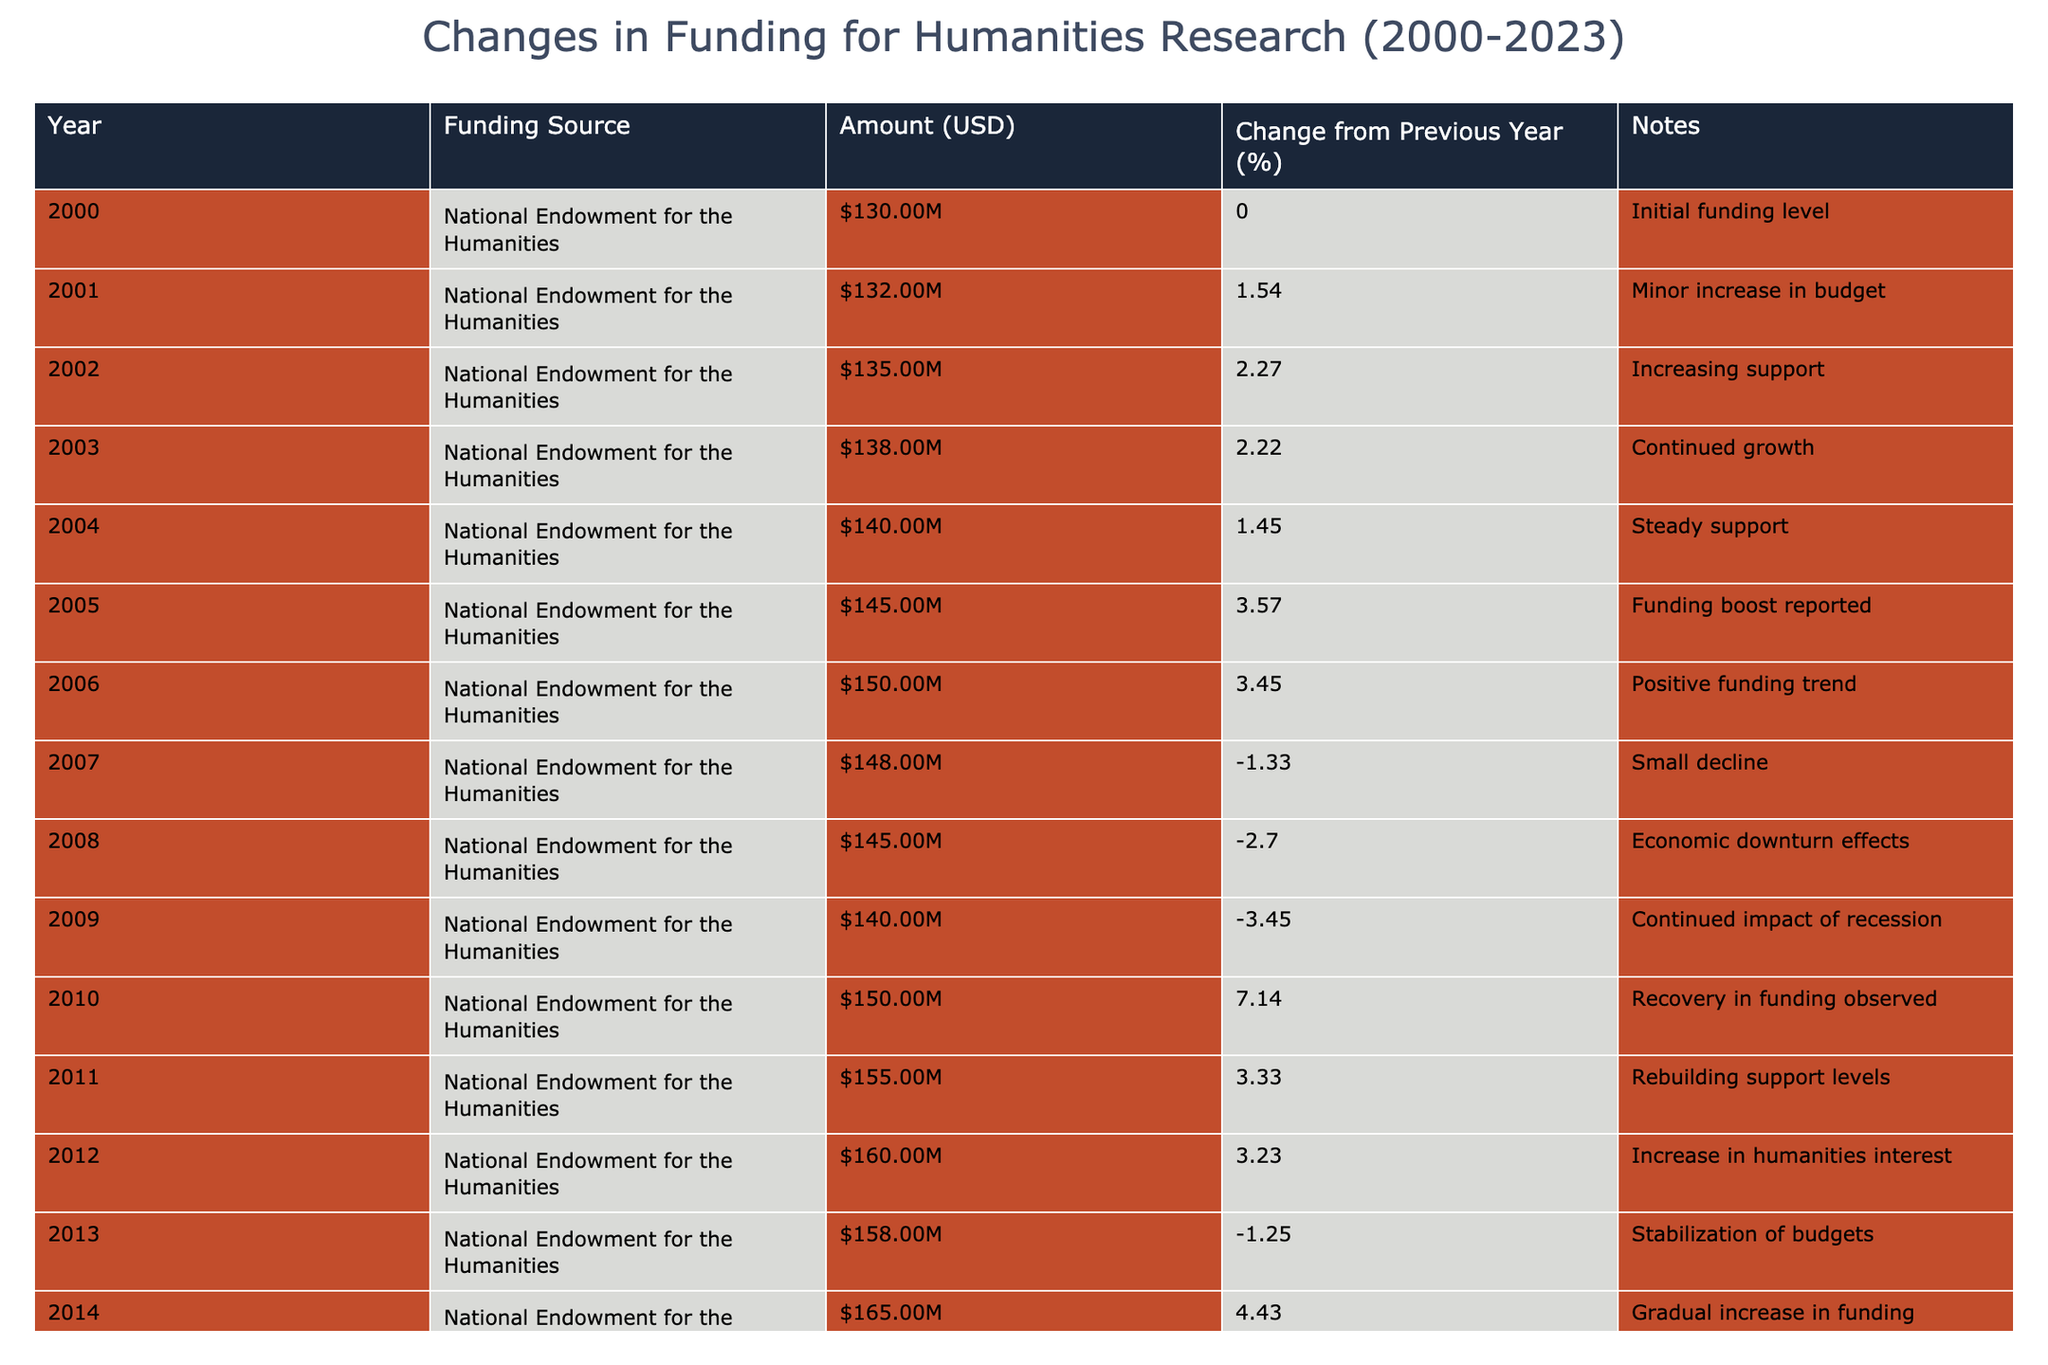What was the funding amount for the National Endowment for the Humanities in 2005? The table shows the funding amount for the year 2005 specifically, which is listed as 145,000,000 USD.
Answer: 145000000 What percentage change occurred in funding from 2017 to 2018? The funding amount in 2017 was 175,000,000 USD and in 2018 it was 180,000,000 USD. The percentage change is calculated as ((180 - 175) / 175) * 100 = 2.86%.
Answer: 2.86% Was there a funding decrease in 2007? The funding for 2007 was 148,000,000 USD, which is lower than the previous year's funding of 150,000,000 USD. This indicates a decline.
Answer: Yes What was the average funding amount over the entire period from 2000 to 2023? The sum of the funding amounts from 2000 to 2023 is 3,361,000,000 USD. There are 24 data points, so the average is calculated as 3,361,000,000 / 24 = 140,041,667 USD.
Answer: 140041667 Did the funding in 2023 surpass the funding in 2000? The funding in 2023 was 200,000,000 USD, which is higher than the funding in 2000 of 130,000,000 USD. Hence, it confirms the increase.
Answer: Yes What was the highest funding amount recorded during this period, and in which year did it occur? The highest funding amount in the table is 200,000,000 USD in the year 2023.
Answer: 200000000 in 2023 What was the percentage change from 2014 to 2015? In 2014, the funding was 165,000,000 USD and in 2015 it was 170,000,000 USD. The percentage change is computed as ((170 - 165) / 165) * 100 = 3.03%.
Answer: 3.03% How many times did the funding amount decrease from one year to the next between 2000 and 2023? Reviewing the table, the funding decreased in 2007, 2008, 2009, and 2016, totaling 4 instances of declines.
Answer: 4 